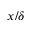Convert formula to latex. <formula><loc_0><loc_0><loc_500><loc_500>x / \delta</formula> 